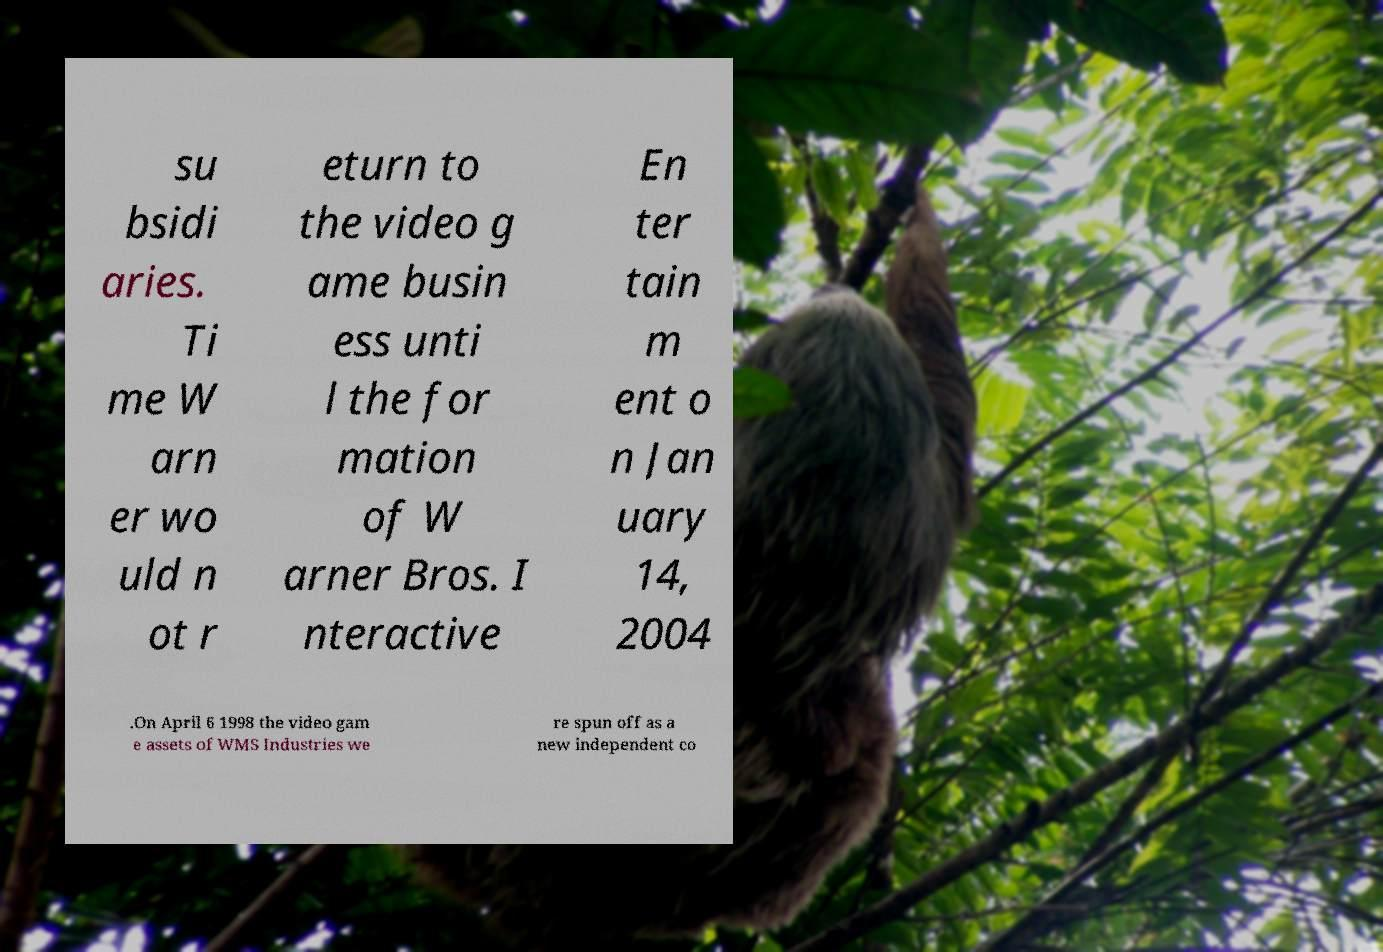Could you extract and type out the text from this image? su bsidi aries. Ti me W arn er wo uld n ot r eturn to the video g ame busin ess unti l the for mation of W arner Bros. I nteractive En ter tain m ent o n Jan uary 14, 2004 .On April 6 1998 the video gam e assets of WMS Industries we re spun off as a new independent co 